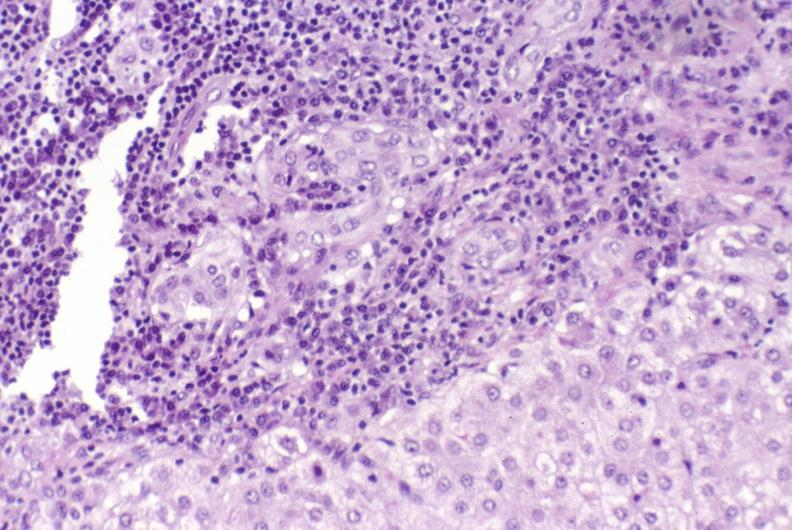what is present?
Answer the question using a single word or phrase. Liver 